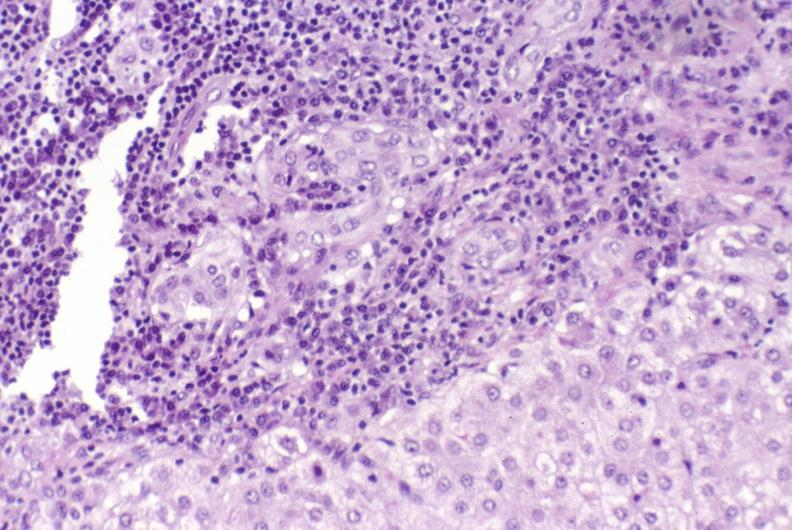what is present?
Answer the question using a single word or phrase. Liver 